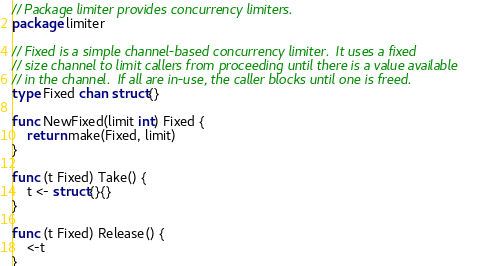<code> <loc_0><loc_0><loc_500><loc_500><_Go_>// Package limiter provides concurrency limiters.
package limiter

// Fixed is a simple channel-based concurrency limiter.  It uses a fixed
// size channel to limit callers from proceeding until there is a value available
// in the channel.  If all are in-use, the caller blocks until one is freed.
type Fixed chan struct{}

func NewFixed(limit int) Fixed {
	return make(Fixed, limit)
}

func (t Fixed) Take() {
	t <- struct{}{}
}

func (t Fixed) Release() {
	<-t
}
</code> 